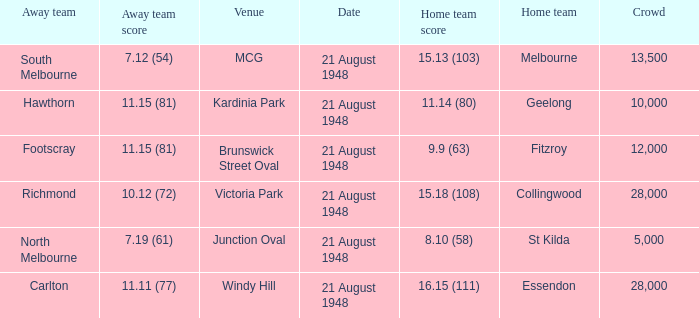With a home team score of 15.18 (108), what was the smallest crowd size recorded? 28000.0. 